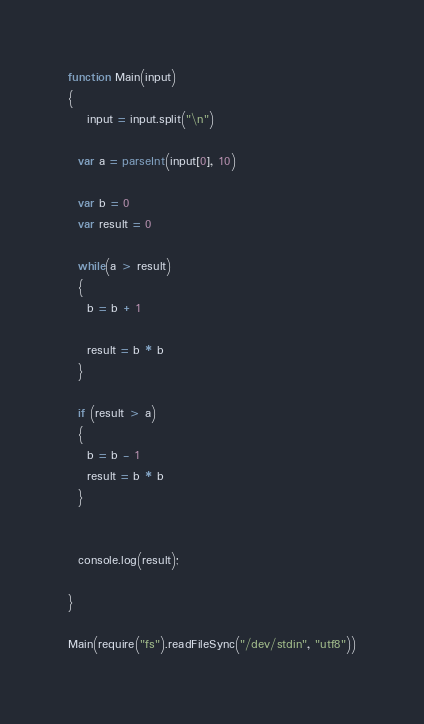Convert code to text. <code><loc_0><loc_0><loc_500><loc_500><_JavaScript_>function Main(input)
{
	input = input.split("\n")

  var a = parseInt(input[0], 10)

  var b = 0
  var result = 0

  while(a > result)
  {
    b = b + 1

    result = b * b
  }

  if (result > a)
  {
    b = b - 1
    result = b * b
  }


  console.log(result);

}

Main(require("fs").readFileSync("/dev/stdin", "utf8"))
</code> 